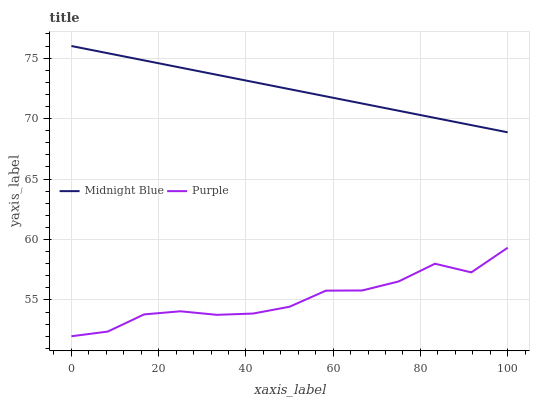Does Purple have the minimum area under the curve?
Answer yes or no. Yes. Does Midnight Blue have the maximum area under the curve?
Answer yes or no. Yes. Does Midnight Blue have the minimum area under the curve?
Answer yes or no. No. Is Midnight Blue the smoothest?
Answer yes or no. Yes. Is Purple the roughest?
Answer yes or no. Yes. Is Midnight Blue the roughest?
Answer yes or no. No. Does Purple have the lowest value?
Answer yes or no. Yes. Does Midnight Blue have the lowest value?
Answer yes or no. No. Does Midnight Blue have the highest value?
Answer yes or no. Yes. Is Purple less than Midnight Blue?
Answer yes or no. Yes. Is Midnight Blue greater than Purple?
Answer yes or no. Yes. Does Purple intersect Midnight Blue?
Answer yes or no. No. 